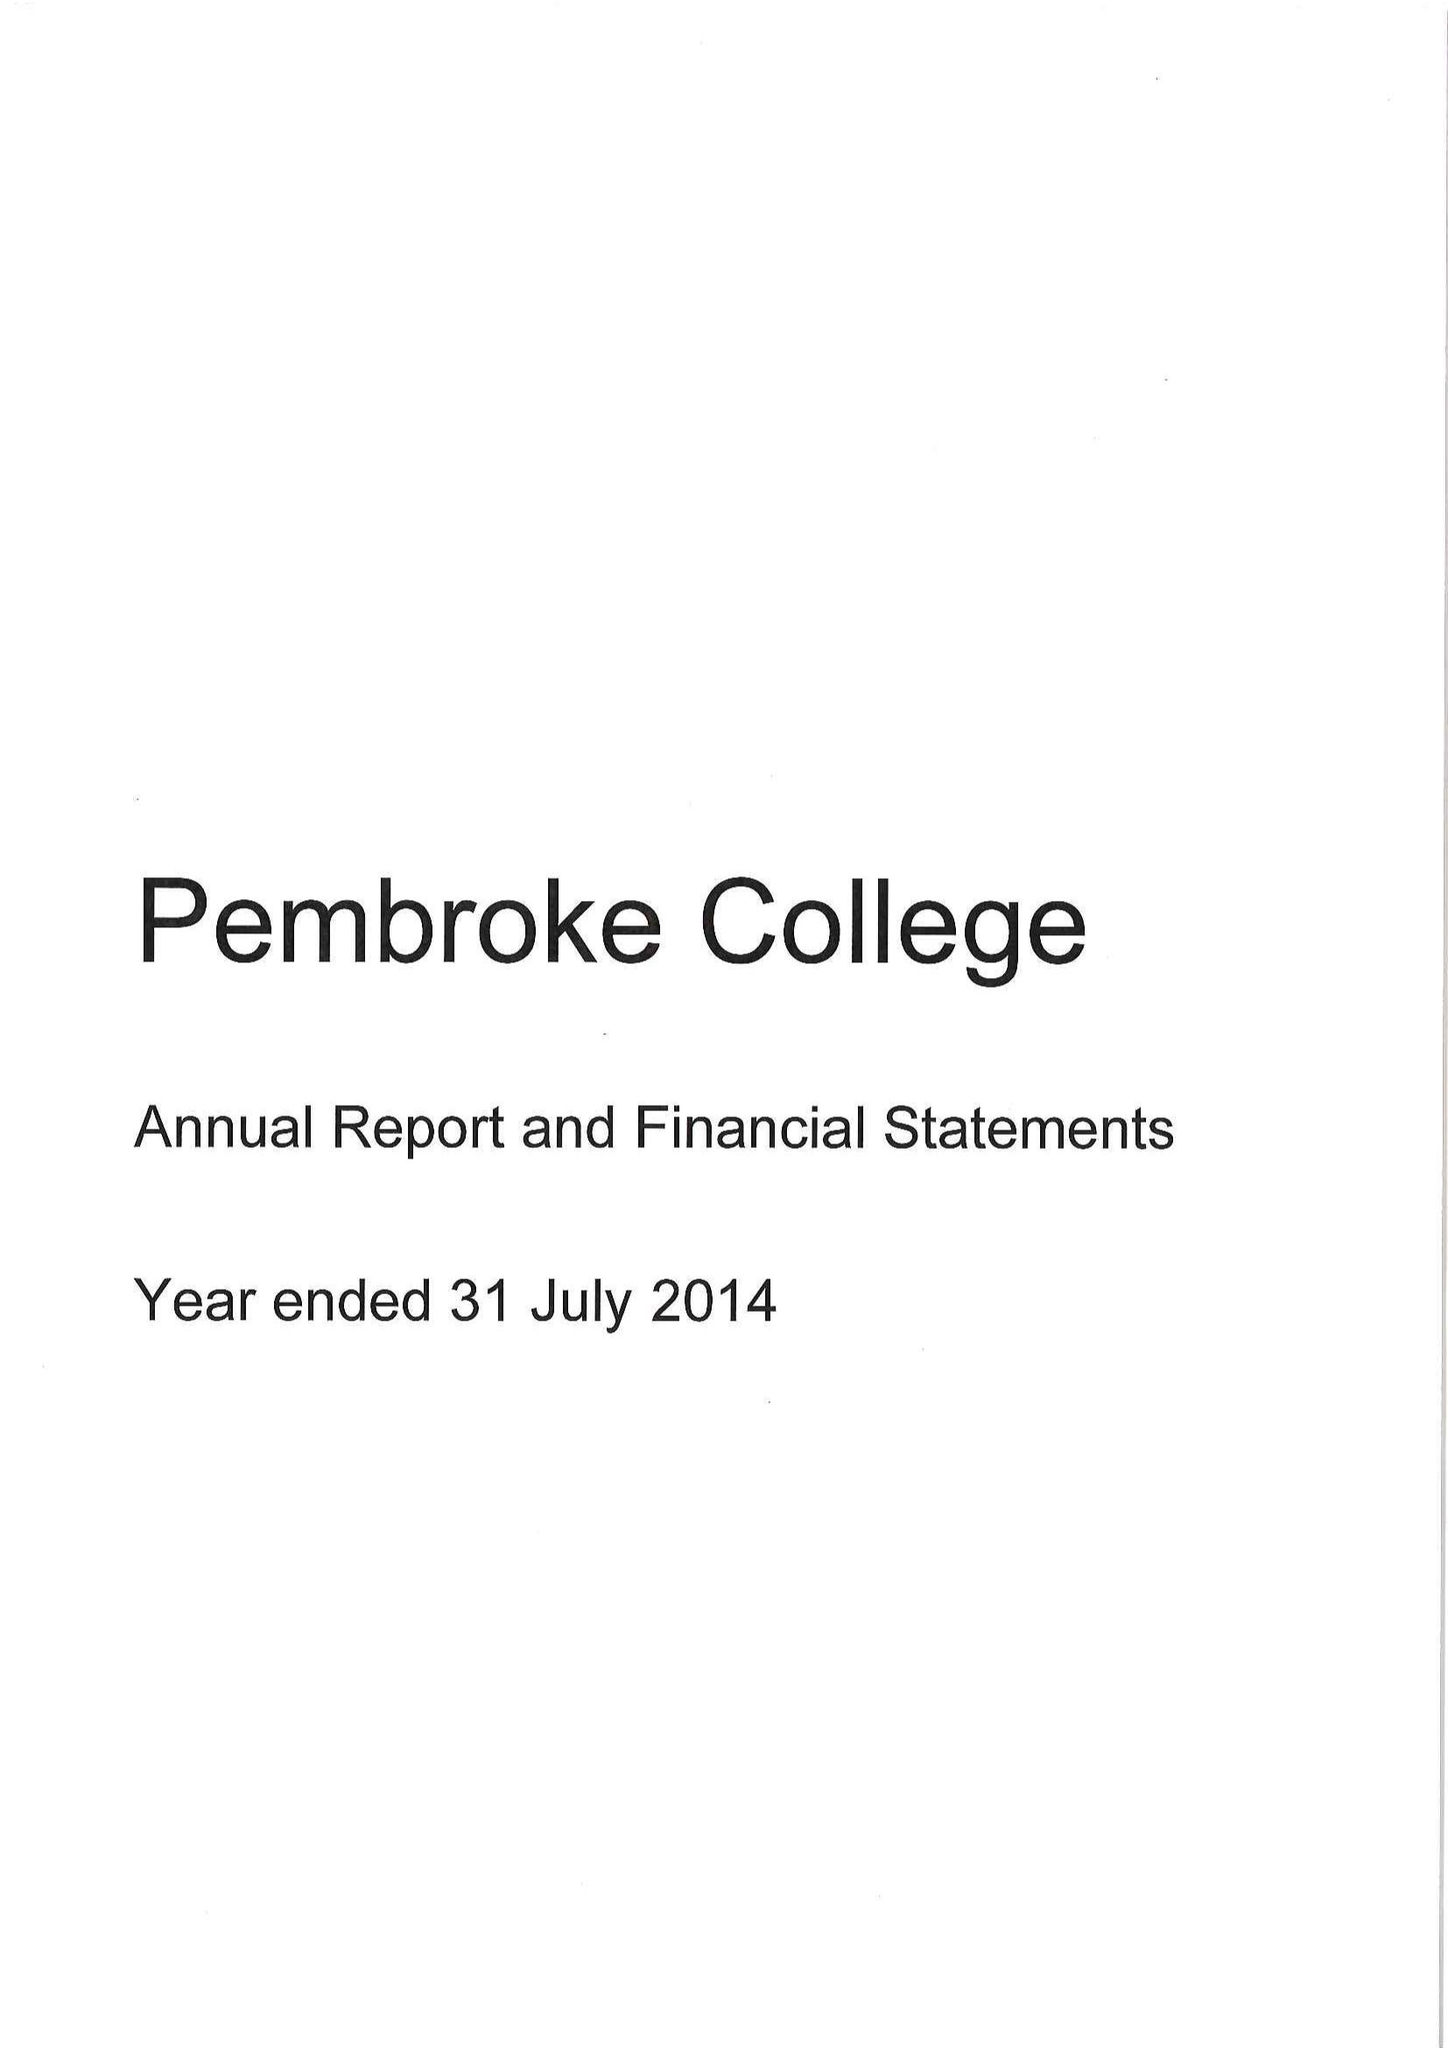What is the value for the charity_name?
Answer the question using a single word or phrase. Master Fellows and Scholars Of Pembroke College 